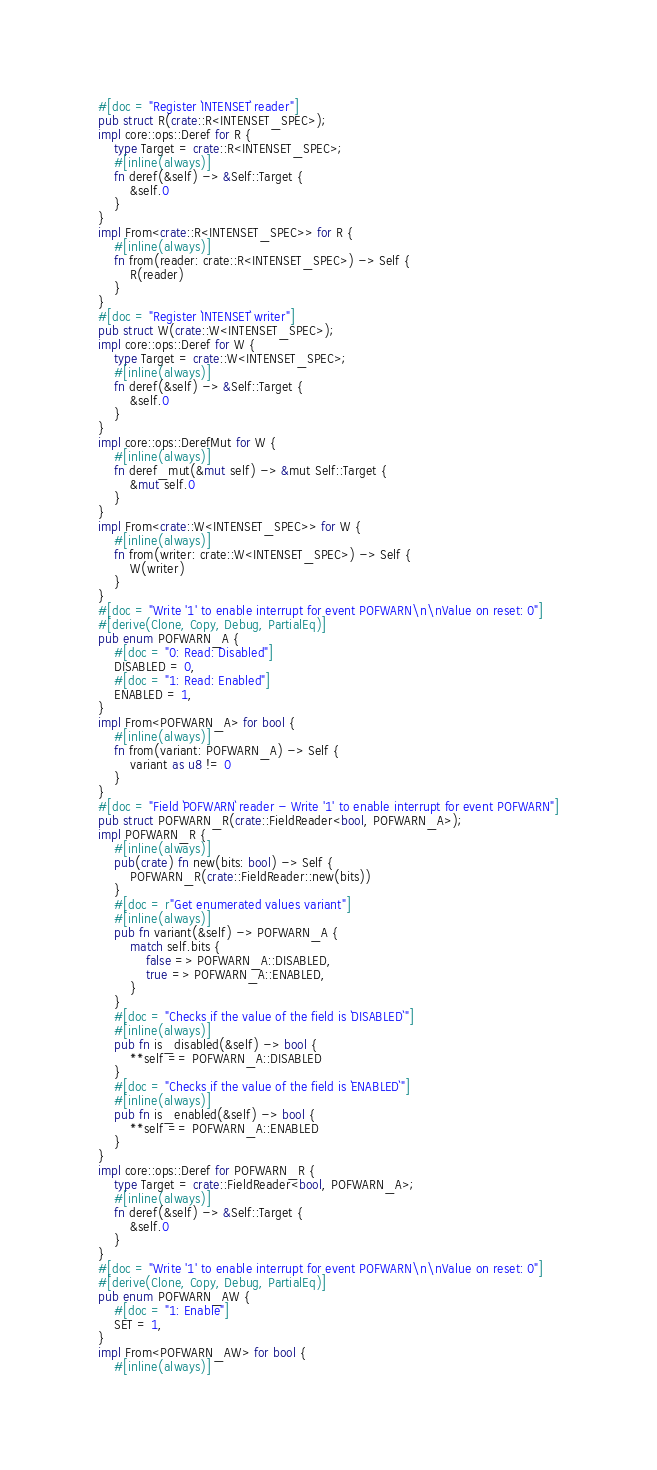Convert code to text. <code><loc_0><loc_0><loc_500><loc_500><_Rust_>#[doc = "Register `INTENSET` reader"]
pub struct R(crate::R<INTENSET_SPEC>);
impl core::ops::Deref for R {
    type Target = crate::R<INTENSET_SPEC>;
    #[inline(always)]
    fn deref(&self) -> &Self::Target {
        &self.0
    }
}
impl From<crate::R<INTENSET_SPEC>> for R {
    #[inline(always)]
    fn from(reader: crate::R<INTENSET_SPEC>) -> Self {
        R(reader)
    }
}
#[doc = "Register `INTENSET` writer"]
pub struct W(crate::W<INTENSET_SPEC>);
impl core::ops::Deref for W {
    type Target = crate::W<INTENSET_SPEC>;
    #[inline(always)]
    fn deref(&self) -> &Self::Target {
        &self.0
    }
}
impl core::ops::DerefMut for W {
    #[inline(always)]
    fn deref_mut(&mut self) -> &mut Self::Target {
        &mut self.0
    }
}
impl From<crate::W<INTENSET_SPEC>> for W {
    #[inline(always)]
    fn from(writer: crate::W<INTENSET_SPEC>) -> Self {
        W(writer)
    }
}
#[doc = "Write '1' to enable interrupt for event POFWARN\n\nValue on reset: 0"]
#[derive(Clone, Copy, Debug, PartialEq)]
pub enum POFWARN_A {
    #[doc = "0: Read: Disabled"]
    DISABLED = 0,
    #[doc = "1: Read: Enabled"]
    ENABLED = 1,
}
impl From<POFWARN_A> for bool {
    #[inline(always)]
    fn from(variant: POFWARN_A) -> Self {
        variant as u8 != 0
    }
}
#[doc = "Field `POFWARN` reader - Write '1' to enable interrupt for event POFWARN"]
pub struct POFWARN_R(crate::FieldReader<bool, POFWARN_A>);
impl POFWARN_R {
    #[inline(always)]
    pub(crate) fn new(bits: bool) -> Self {
        POFWARN_R(crate::FieldReader::new(bits))
    }
    #[doc = r"Get enumerated values variant"]
    #[inline(always)]
    pub fn variant(&self) -> POFWARN_A {
        match self.bits {
            false => POFWARN_A::DISABLED,
            true => POFWARN_A::ENABLED,
        }
    }
    #[doc = "Checks if the value of the field is `DISABLED`"]
    #[inline(always)]
    pub fn is_disabled(&self) -> bool {
        **self == POFWARN_A::DISABLED
    }
    #[doc = "Checks if the value of the field is `ENABLED`"]
    #[inline(always)]
    pub fn is_enabled(&self) -> bool {
        **self == POFWARN_A::ENABLED
    }
}
impl core::ops::Deref for POFWARN_R {
    type Target = crate::FieldReader<bool, POFWARN_A>;
    #[inline(always)]
    fn deref(&self) -> &Self::Target {
        &self.0
    }
}
#[doc = "Write '1' to enable interrupt for event POFWARN\n\nValue on reset: 0"]
#[derive(Clone, Copy, Debug, PartialEq)]
pub enum POFWARN_AW {
    #[doc = "1: Enable"]
    SET = 1,
}
impl From<POFWARN_AW> for bool {
    #[inline(always)]</code> 